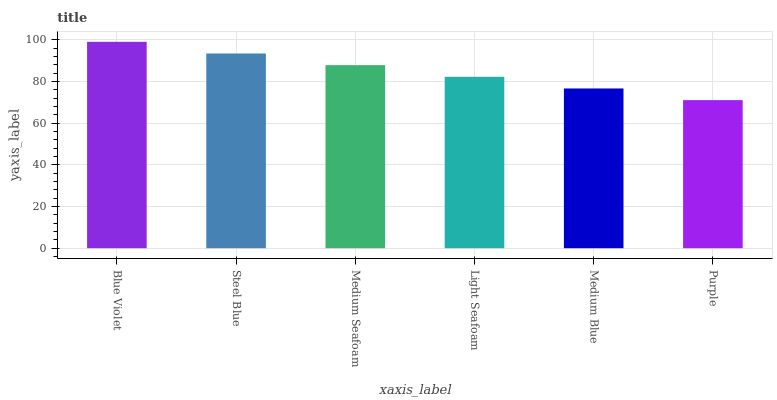Is Purple the minimum?
Answer yes or no. Yes. Is Blue Violet the maximum?
Answer yes or no. Yes. Is Steel Blue the minimum?
Answer yes or no. No. Is Steel Blue the maximum?
Answer yes or no. No. Is Blue Violet greater than Steel Blue?
Answer yes or no. Yes. Is Steel Blue less than Blue Violet?
Answer yes or no. Yes. Is Steel Blue greater than Blue Violet?
Answer yes or no. No. Is Blue Violet less than Steel Blue?
Answer yes or no. No. Is Medium Seafoam the high median?
Answer yes or no. Yes. Is Light Seafoam the low median?
Answer yes or no. Yes. Is Light Seafoam the high median?
Answer yes or no. No. Is Steel Blue the low median?
Answer yes or no. No. 